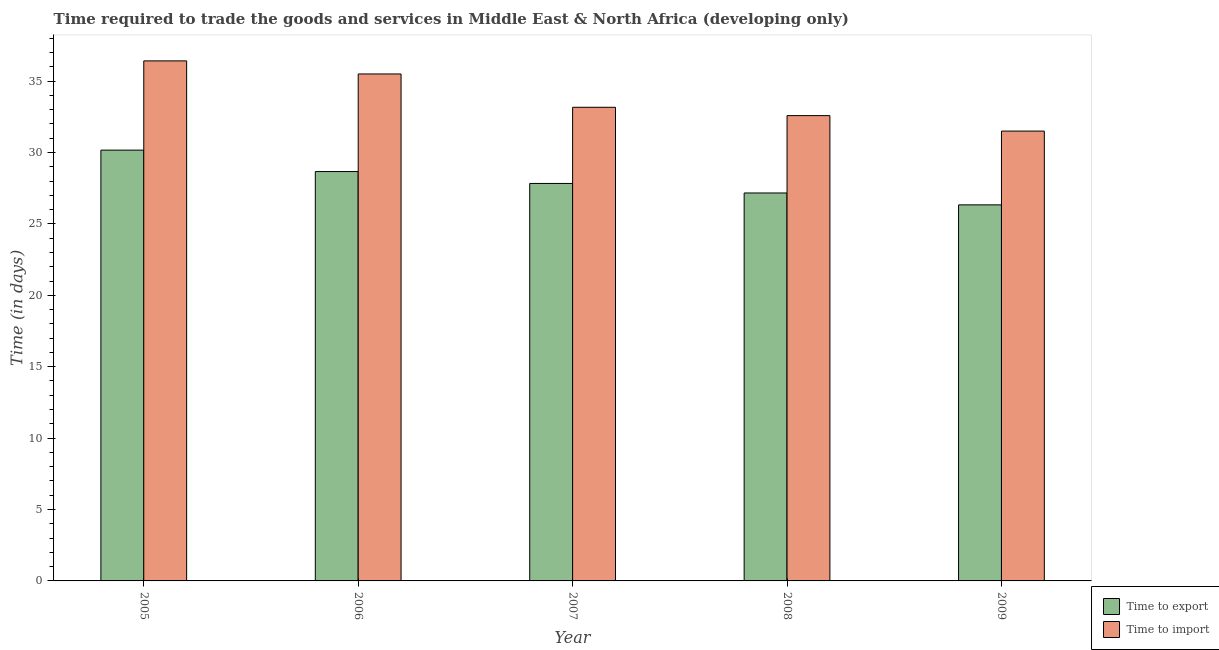How many different coloured bars are there?
Make the answer very short. 2. How many groups of bars are there?
Give a very brief answer. 5. Are the number of bars on each tick of the X-axis equal?
Ensure brevity in your answer.  Yes. In how many cases, is the number of bars for a given year not equal to the number of legend labels?
Make the answer very short. 0. What is the time to export in 2008?
Ensure brevity in your answer.  27.17. Across all years, what is the maximum time to import?
Provide a succinct answer. 36.42. Across all years, what is the minimum time to import?
Give a very brief answer. 31.5. In which year was the time to export maximum?
Offer a very short reply. 2005. What is the total time to import in the graph?
Provide a succinct answer. 169.17. What is the difference between the time to import in 2006 and the time to export in 2008?
Your answer should be compact. 2.92. What is the average time to export per year?
Provide a short and direct response. 28.03. What is the ratio of the time to export in 2005 to that in 2009?
Offer a terse response. 1.15. Is the time to export in 2005 less than that in 2006?
Offer a terse response. No. What is the difference between the highest and the second highest time to import?
Ensure brevity in your answer.  0.92. What is the difference between the highest and the lowest time to export?
Your response must be concise. 3.83. In how many years, is the time to export greater than the average time to export taken over all years?
Ensure brevity in your answer.  2. What does the 1st bar from the left in 2008 represents?
Your answer should be compact. Time to export. What does the 1st bar from the right in 2005 represents?
Give a very brief answer. Time to import. Are all the bars in the graph horizontal?
Offer a very short reply. No. What is the difference between two consecutive major ticks on the Y-axis?
Your answer should be compact. 5. Are the values on the major ticks of Y-axis written in scientific E-notation?
Give a very brief answer. No. Does the graph contain grids?
Provide a short and direct response. No. How are the legend labels stacked?
Provide a succinct answer. Vertical. What is the title of the graph?
Provide a short and direct response. Time required to trade the goods and services in Middle East & North Africa (developing only). Does "Technicians" appear as one of the legend labels in the graph?
Keep it short and to the point. No. What is the label or title of the X-axis?
Keep it short and to the point. Year. What is the label or title of the Y-axis?
Your answer should be very brief. Time (in days). What is the Time (in days) of Time to export in 2005?
Your answer should be very brief. 30.17. What is the Time (in days) of Time to import in 2005?
Ensure brevity in your answer.  36.42. What is the Time (in days) of Time to export in 2006?
Provide a succinct answer. 28.67. What is the Time (in days) of Time to import in 2006?
Your response must be concise. 35.5. What is the Time (in days) of Time to export in 2007?
Give a very brief answer. 27.83. What is the Time (in days) in Time to import in 2007?
Ensure brevity in your answer.  33.17. What is the Time (in days) of Time to export in 2008?
Provide a short and direct response. 27.17. What is the Time (in days) of Time to import in 2008?
Keep it short and to the point. 32.58. What is the Time (in days) of Time to export in 2009?
Give a very brief answer. 26.33. What is the Time (in days) in Time to import in 2009?
Provide a succinct answer. 31.5. Across all years, what is the maximum Time (in days) in Time to export?
Your answer should be very brief. 30.17. Across all years, what is the maximum Time (in days) in Time to import?
Keep it short and to the point. 36.42. Across all years, what is the minimum Time (in days) of Time to export?
Keep it short and to the point. 26.33. Across all years, what is the minimum Time (in days) of Time to import?
Ensure brevity in your answer.  31.5. What is the total Time (in days) in Time to export in the graph?
Offer a very short reply. 140.17. What is the total Time (in days) in Time to import in the graph?
Make the answer very short. 169.17. What is the difference between the Time (in days) in Time to export in 2005 and that in 2006?
Ensure brevity in your answer.  1.5. What is the difference between the Time (in days) in Time to export in 2005 and that in 2007?
Keep it short and to the point. 2.33. What is the difference between the Time (in days) in Time to export in 2005 and that in 2008?
Make the answer very short. 3. What is the difference between the Time (in days) in Time to import in 2005 and that in 2008?
Ensure brevity in your answer.  3.83. What is the difference between the Time (in days) of Time to export in 2005 and that in 2009?
Offer a terse response. 3.83. What is the difference between the Time (in days) of Time to import in 2005 and that in 2009?
Ensure brevity in your answer.  4.92. What is the difference between the Time (in days) of Time to import in 2006 and that in 2007?
Your response must be concise. 2.33. What is the difference between the Time (in days) of Time to export in 2006 and that in 2008?
Your response must be concise. 1.5. What is the difference between the Time (in days) of Time to import in 2006 and that in 2008?
Your answer should be very brief. 2.92. What is the difference between the Time (in days) of Time to export in 2006 and that in 2009?
Ensure brevity in your answer.  2.33. What is the difference between the Time (in days) in Time to import in 2007 and that in 2008?
Offer a terse response. 0.58. What is the difference between the Time (in days) in Time to export in 2005 and the Time (in days) in Time to import in 2006?
Your answer should be very brief. -5.33. What is the difference between the Time (in days) in Time to export in 2005 and the Time (in days) in Time to import in 2007?
Give a very brief answer. -3. What is the difference between the Time (in days) of Time to export in 2005 and the Time (in days) of Time to import in 2008?
Your answer should be compact. -2.42. What is the difference between the Time (in days) of Time to export in 2005 and the Time (in days) of Time to import in 2009?
Your answer should be compact. -1.33. What is the difference between the Time (in days) in Time to export in 2006 and the Time (in days) in Time to import in 2008?
Your answer should be compact. -3.92. What is the difference between the Time (in days) in Time to export in 2006 and the Time (in days) in Time to import in 2009?
Your response must be concise. -2.83. What is the difference between the Time (in days) in Time to export in 2007 and the Time (in days) in Time to import in 2008?
Provide a succinct answer. -4.75. What is the difference between the Time (in days) in Time to export in 2007 and the Time (in days) in Time to import in 2009?
Offer a very short reply. -3.67. What is the difference between the Time (in days) in Time to export in 2008 and the Time (in days) in Time to import in 2009?
Ensure brevity in your answer.  -4.33. What is the average Time (in days) in Time to export per year?
Your answer should be compact. 28.03. What is the average Time (in days) in Time to import per year?
Your response must be concise. 33.83. In the year 2005, what is the difference between the Time (in days) in Time to export and Time (in days) in Time to import?
Keep it short and to the point. -6.25. In the year 2006, what is the difference between the Time (in days) in Time to export and Time (in days) in Time to import?
Keep it short and to the point. -6.83. In the year 2007, what is the difference between the Time (in days) of Time to export and Time (in days) of Time to import?
Keep it short and to the point. -5.33. In the year 2008, what is the difference between the Time (in days) of Time to export and Time (in days) of Time to import?
Your response must be concise. -5.42. In the year 2009, what is the difference between the Time (in days) of Time to export and Time (in days) of Time to import?
Make the answer very short. -5.17. What is the ratio of the Time (in days) in Time to export in 2005 to that in 2006?
Provide a short and direct response. 1.05. What is the ratio of the Time (in days) of Time to import in 2005 to that in 2006?
Offer a very short reply. 1.03. What is the ratio of the Time (in days) in Time to export in 2005 to that in 2007?
Provide a succinct answer. 1.08. What is the ratio of the Time (in days) of Time to import in 2005 to that in 2007?
Provide a succinct answer. 1.1. What is the ratio of the Time (in days) of Time to export in 2005 to that in 2008?
Offer a very short reply. 1.11. What is the ratio of the Time (in days) of Time to import in 2005 to that in 2008?
Your response must be concise. 1.12. What is the ratio of the Time (in days) in Time to export in 2005 to that in 2009?
Your response must be concise. 1.15. What is the ratio of the Time (in days) of Time to import in 2005 to that in 2009?
Keep it short and to the point. 1.16. What is the ratio of the Time (in days) of Time to export in 2006 to that in 2007?
Give a very brief answer. 1.03. What is the ratio of the Time (in days) in Time to import in 2006 to that in 2007?
Offer a very short reply. 1.07. What is the ratio of the Time (in days) in Time to export in 2006 to that in 2008?
Give a very brief answer. 1.06. What is the ratio of the Time (in days) of Time to import in 2006 to that in 2008?
Ensure brevity in your answer.  1.09. What is the ratio of the Time (in days) in Time to export in 2006 to that in 2009?
Your answer should be very brief. 1.09. What is the ratio of the Time (in days) of Time to import in 2006 to that in 2009?
Ensure brevity in your answer.  1.13. What is the ratio of the Time (in days) in Time to export in 2007 to that in 2008?
Offer a very short reply. 1.02. What is the ratio of the Time (in days) in Time to import in 2007 to that in 2008?
Give a very brief answer. 1.02. What is the ratio of the Time (in days) of Time to export in 2007 to that in 2009?
Provide a short and direct response. 1.06. What is the ratio of the Time (in days) in Time to import in 2007 to that in 2009?
Ensure brevity in your answer.  1.05. What is the ratio of the Time (in days) of Time to export in 2008 to that in 2009?
Offer a very short reply. 1.03. What is the ratio of the Time (in days) of Time to import in 2008 to that in 2009?
Provide a succinct answer. 1.03. What is the difference between the highest and the second highest Time (in days) of Time to export?
Provide a succinct answer. 1.5. What is the difference between the highest and the second highest Time (in days) in Time to import?
Give a very brief answer. 0.92. What is the difference between the highest and the lowest Time (in days) in Time to export?
Your answer should be compact. 3.83. What is the difference between the highest and the lowest Time (in days) of Time to import?
Provide a succinct answer. 4.92. 